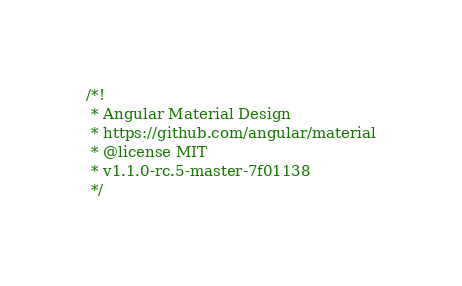Convert code to text. <code><loc_0><loc_0><loc_500><loc_500><_JavaScript_>/*!
 * Angular Material Design
 * https://github.com/angular/material
 * @license MIT
 * v1.1.0-rc.5-master-7f01138
 */</code> 